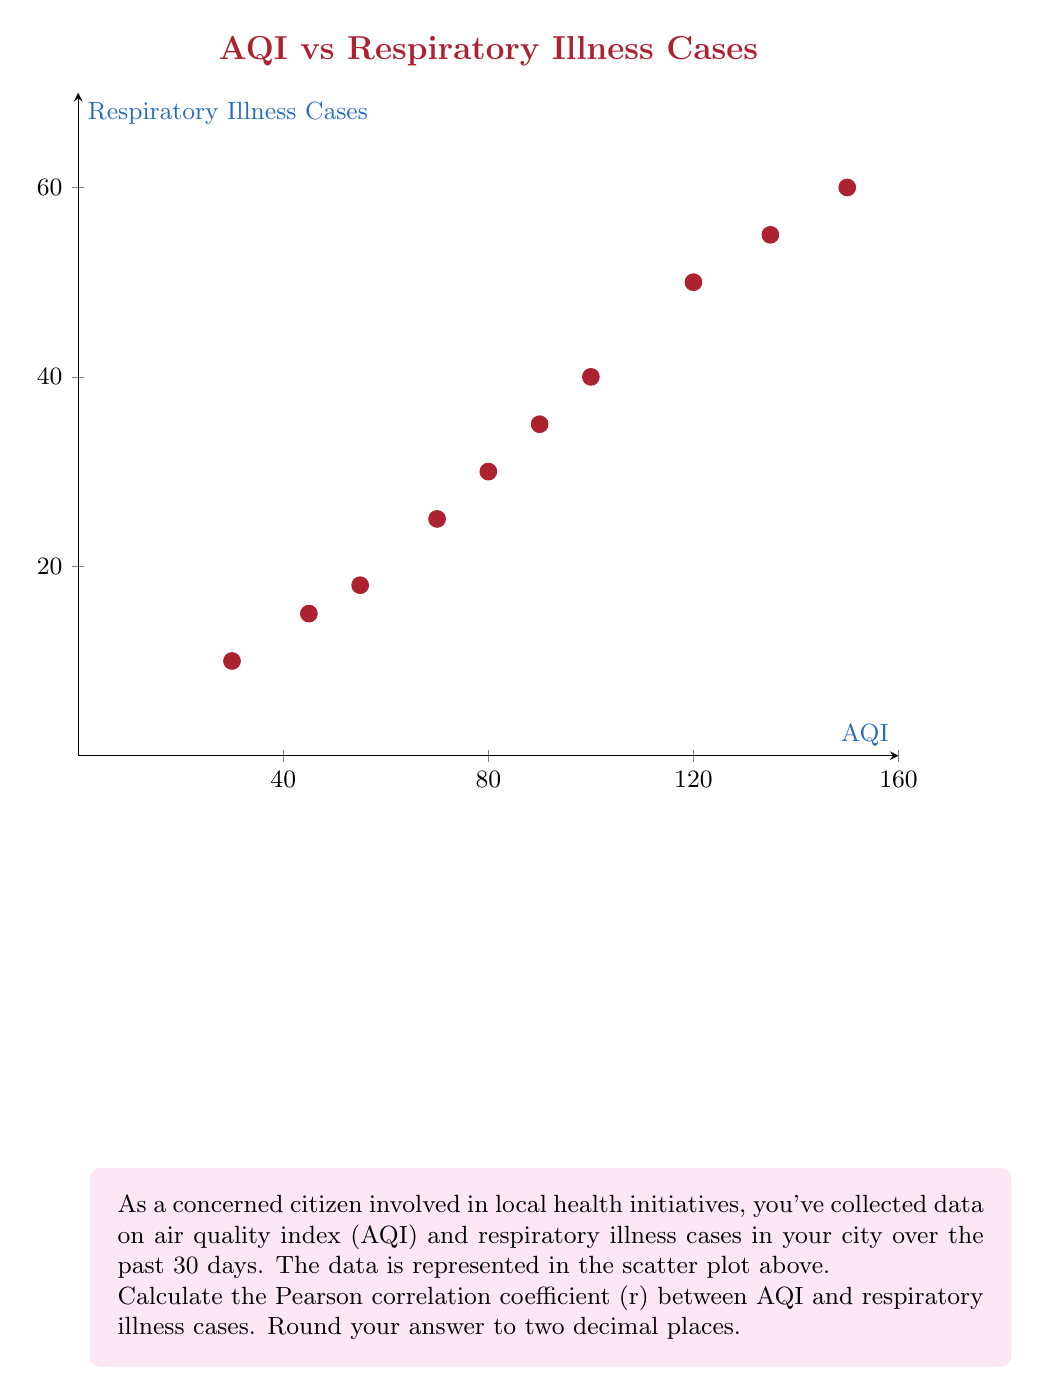Can you solve this math problem? To calculate the Pearson correlation coefficient (r), we'll use the formula:

$$ r = \frac{\sum_{i=1}^{n} (x_i - \bar{x})(y_i - \bar{y})}{\sqrt{\sum_{i=1}^{n} (x_i - \bar{x})^2 \sum_{i=1}^{n} (y_i - \bar{y})^2}} $$

Where:
$x_i$ = AQI values
$y_i$ = Respiratory illness cases
$\bar{x}$ = Mean of AQI values
$\bar{y}$ = Mean of respiratory illness cases
$n$ = Number of data points (10 in this case)

Step 1: Calculate means
$\bar{x} = \frac{30+45+55+70+80+90+100+120+135+150}{10} = 87.5$
$\bar{y} = \frac{10+15+18+25+30+35+40+50+55+60}{10} = 33.8$

Step 2: Calculate $(x_i - \bar{x})$, $(y_i - \bar{y})$, $(x_i - \bar{x})^2$, $(y_i - \bar{y})^2$, and $(x_i - \bar{x})(y_i - \bar{y})$ for each data point.

Step 3: Sum up the calculated values:
$\sum (x_i - \bar{x})(y_i - \bar{y}) = 8281.5$
$\sum (x_i - \bar{x})^2 = 20306.25$
$\sum (y_i - \bar{y})^2 = 2701.8$

Step 4: Apply the formula:

$$ r = \frac{8281.5}{\sqrt{20306.25 \times 2701.8}} = 0.9947 $$

Step 5: Round to two decimal places: 0.99
Answer: 0.99 